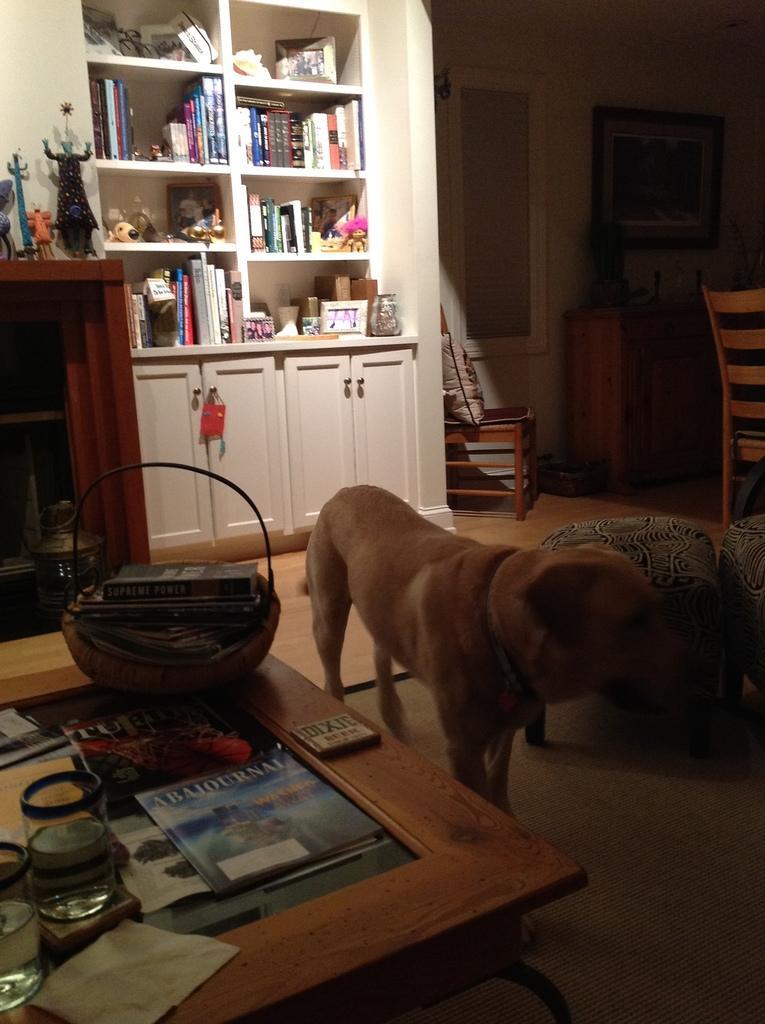Describe this image in one or two sentences. This is a room. And in this room there is a table. On the table there are some books, two glasses with water also a basket containing some books. Near to the table there is a door and two chairs are there. In the background there is a cupboard. In this cupboard there are many things. It includes books, some toys , photo frame etc. And on the wall there is a photo frame. 